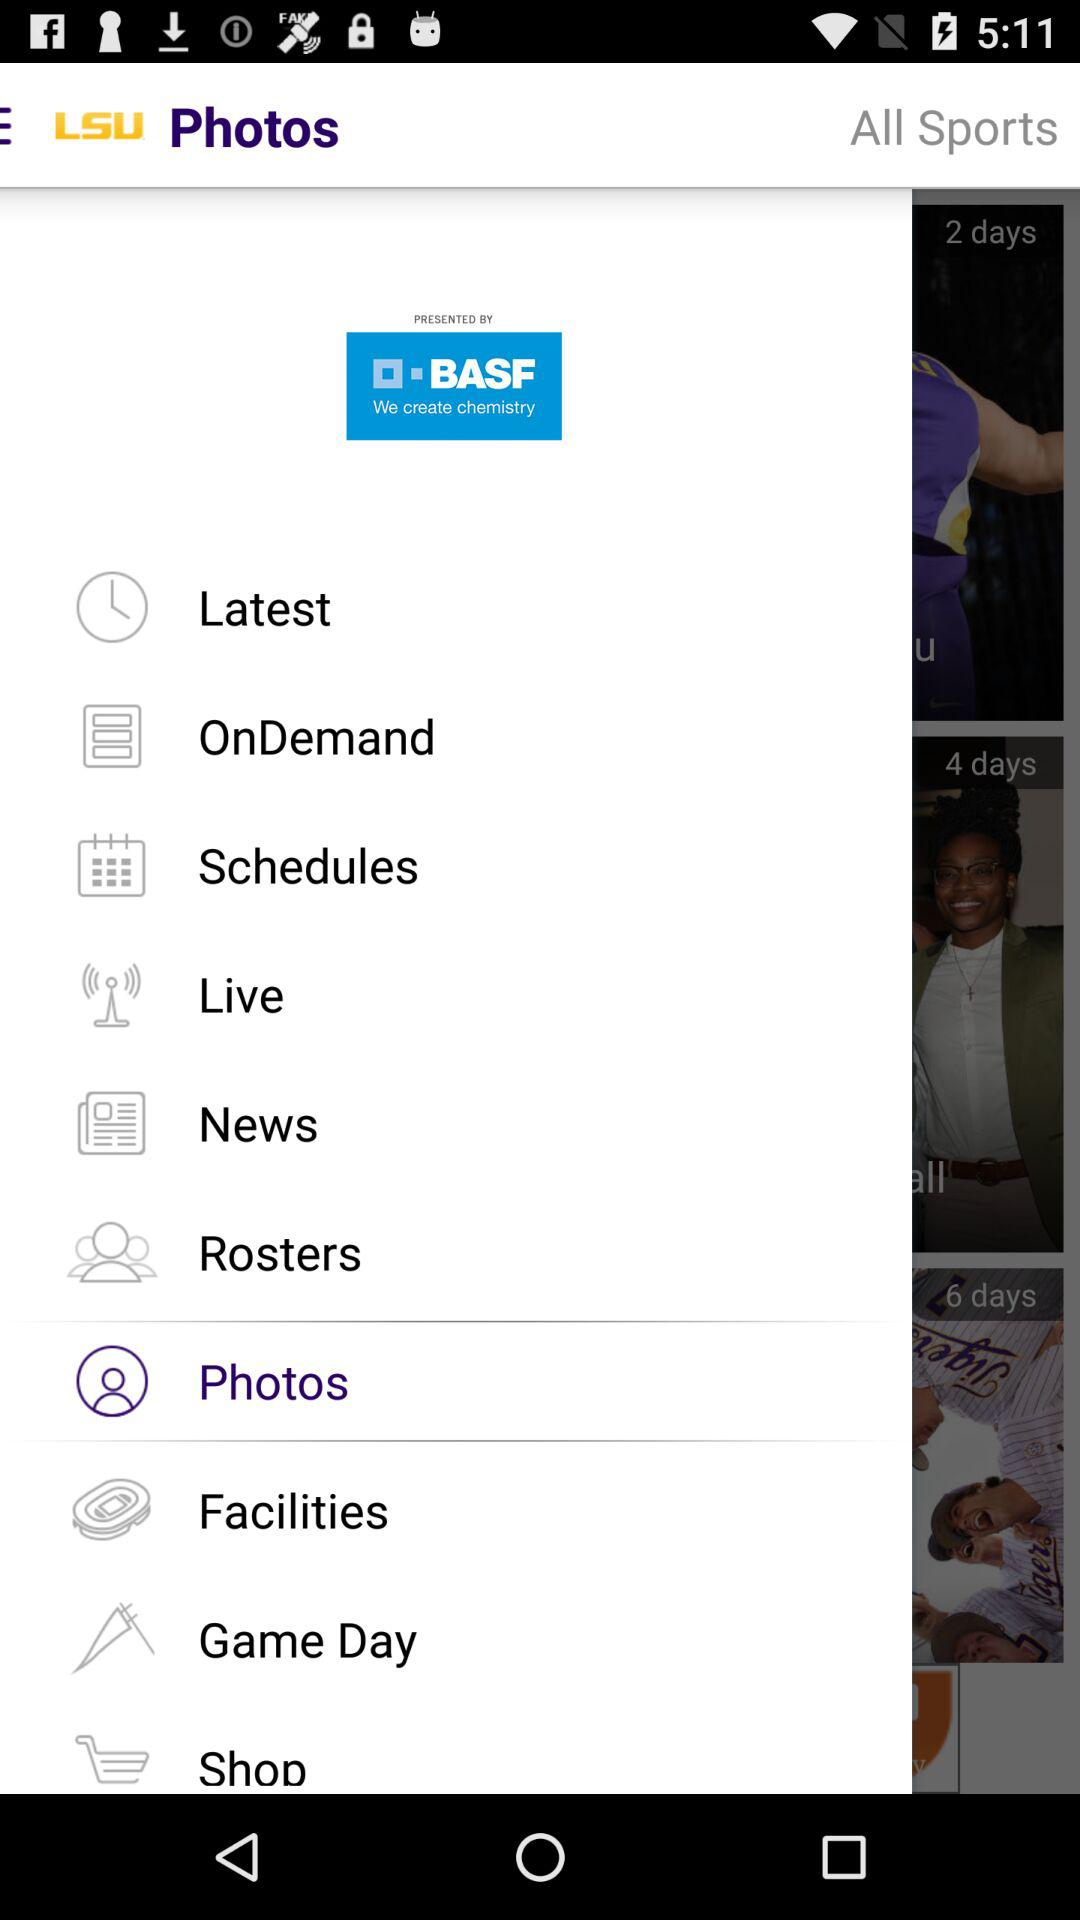What is the application name? The application name is "LSU". 